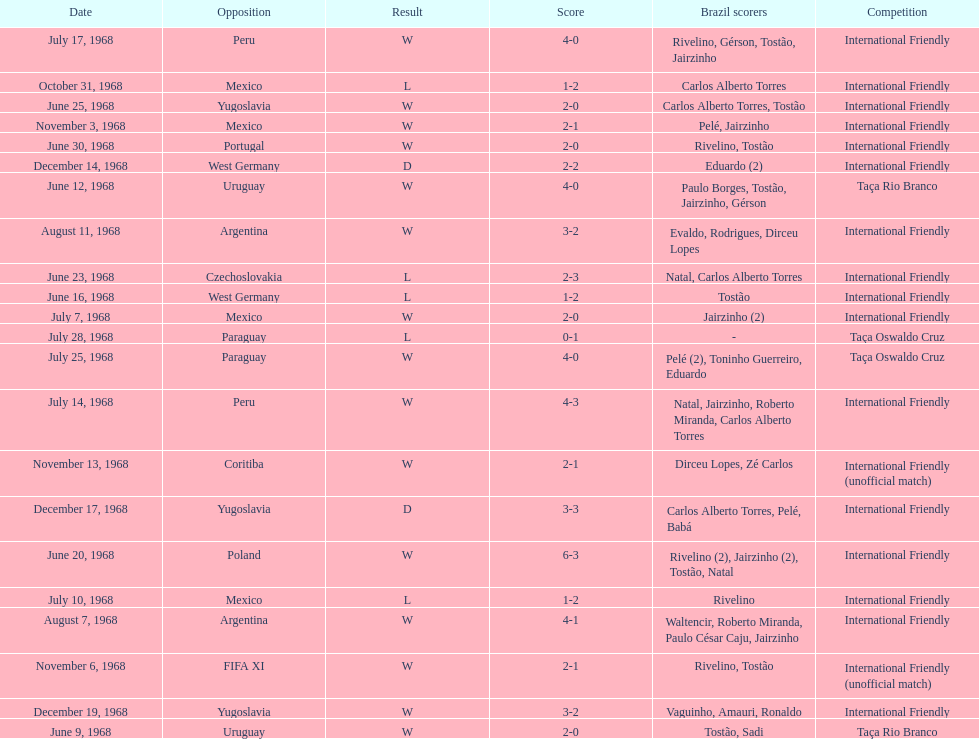In the international friendly competition, how many times have brazil and argentina faced each other? 2. Could you help me parse every detail presented in this table? {'header': ['Date', 'Opposition', 'Result', 'Score', 'Brazil scorers', 'Competition'], 'rows': [['July 17, 1968', 'Peru', 'W', '4-0', 'Rivelino, Gérson, Tostão, Jairzinho', 'International Friendly'], ['October 31, 1968', 'Mexico', 'L', '1-2', 'Carlos Alberto Torres', 'International Friendly'], ['June 25, 1968', 'Yugoslavia', 'W', '2-0', 'Carlos Alberto Torres, Tostão', 'International Friendly'], ['November 3, 1968', 'Mexico', 'W', '2-1', 'Pelé, Jairzinho', 'International Friendly'], ['June 30, 1968', 'Portugal', 'W', '2-0', 'Rivelino, Tostão', 'International Friendly'], ['December 14, 1968', 'West Germany', 'D', '2-2', 'Eduardo (2)', 'International Friendly'], ['June 12, 1968', 'Uruguay', 'W', '4-0', 'Paulo Borges, Tostão, Jairzinho, Gérson', 'Taça Rio Branco'], ['August 11, 1968', 'Argentina', 'W', '3-2', 'Evaldo, Rodrigues, Dirceu Lopes', 'International Friendly'], ['June 23, 1968', 'Czechoslovakia', 'L', '2-3', 'Natal, Carlos Alberto Torres', 'International Friendly'], ['June 16, 1968', 'West Germany', 'L', '1-2', 'Tostão', 'International Friendly'], ['July 7, 1968', 'Mexico', 'W', '2-0', 'Jairzinho (2)', 'International Friendly'], ['July 28, 1968', 'Paraguay', 'L', '0-1', '-', 'Taça Oswaldo Cruz'], ['July 25, 1968', 'Paraguay', 'W', '4-0', 'Pelé (2), Toninho Guerreiro, Eduardo', 'Taça Oswaldo Cruz'], ['July 14, 1968', 'Peru', 'W', '4-3', 'Natal, Jairzinho, Roberto Miranda, Carlos Alberto Torres', 'International Friendly'], ['November 13, 1968', 'Coritiba', 'W', '2-1', 'Dirceu Lopes, Zé Carlos', 'International Friendly (unofficial match)'], ['December 17, 1968', 'Yugoslavia', 'D', '3-3', 'Carlos Alberto Torres, Pelé, Babá', 'International Friendly'], ['June 20, 1968', 'Poland', 'W', '6-3', 'Rivelino (2), Jairzinho (2), Tostão, Natal', 'International Friendly'], ['July 10, 1968', 'Mexico', 'L', '1-2', 'Rivelino', 'International Friendly'], ['August 7, 1968', 'Argentina', 'W', '4-1', 'Waltencir, Roberto Miranda, Paulo César Caju, Jairzinho', 'International Friendly'], ['November 6, 1968', 'FIFA XI', 'W', '2-1', 'Rivelino, Tostão', 'International Friendly (unofficial match)'], ['December 19, 1968', 'Yugoslavia', 'W', '3-2', 'Vaguinho, Amauri, Ronaldo', 'International Friendly'], ['June 9, 1968', 'Uruguay', 'W', '2-0', 'Tostão, Sadi', 'Taça Rio Branco']]} 